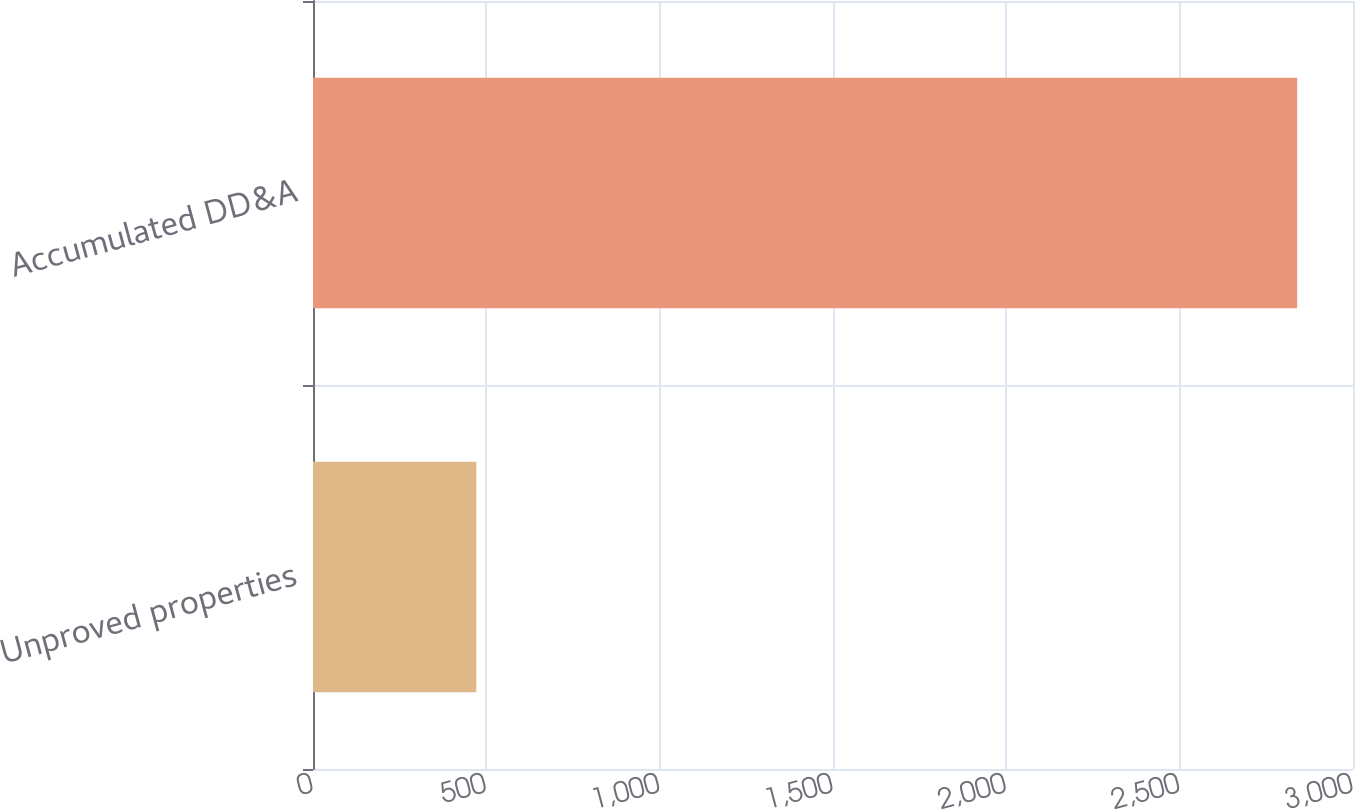<chart> <loc_0><loc_0><loc_500><loc_500><bar_chart><fcel>Unproved properties<fcel>Accumulated DD&A<nl><fcel>471<fcel>2839<nl></chart> 